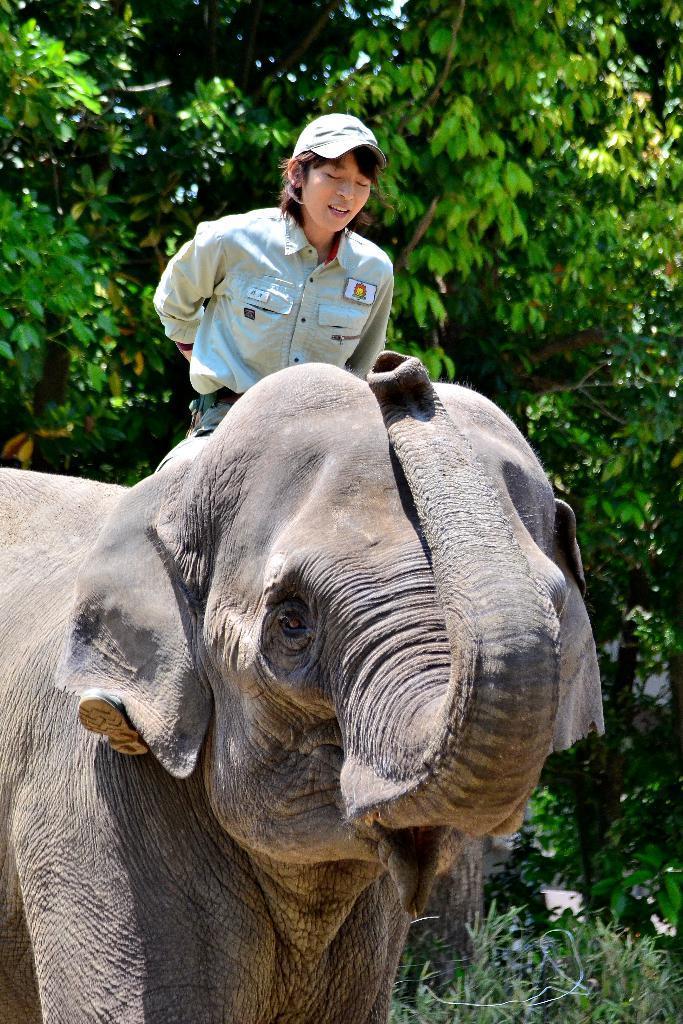In one or two sentences, can you explain what this image depicts? In the foreground of the image, elephant is visible which is half, on which a person is sitting wearing a cap. In the background, there are trees visible and a sky visible blue in color. It looks as if the image is taken during a sunny day. 